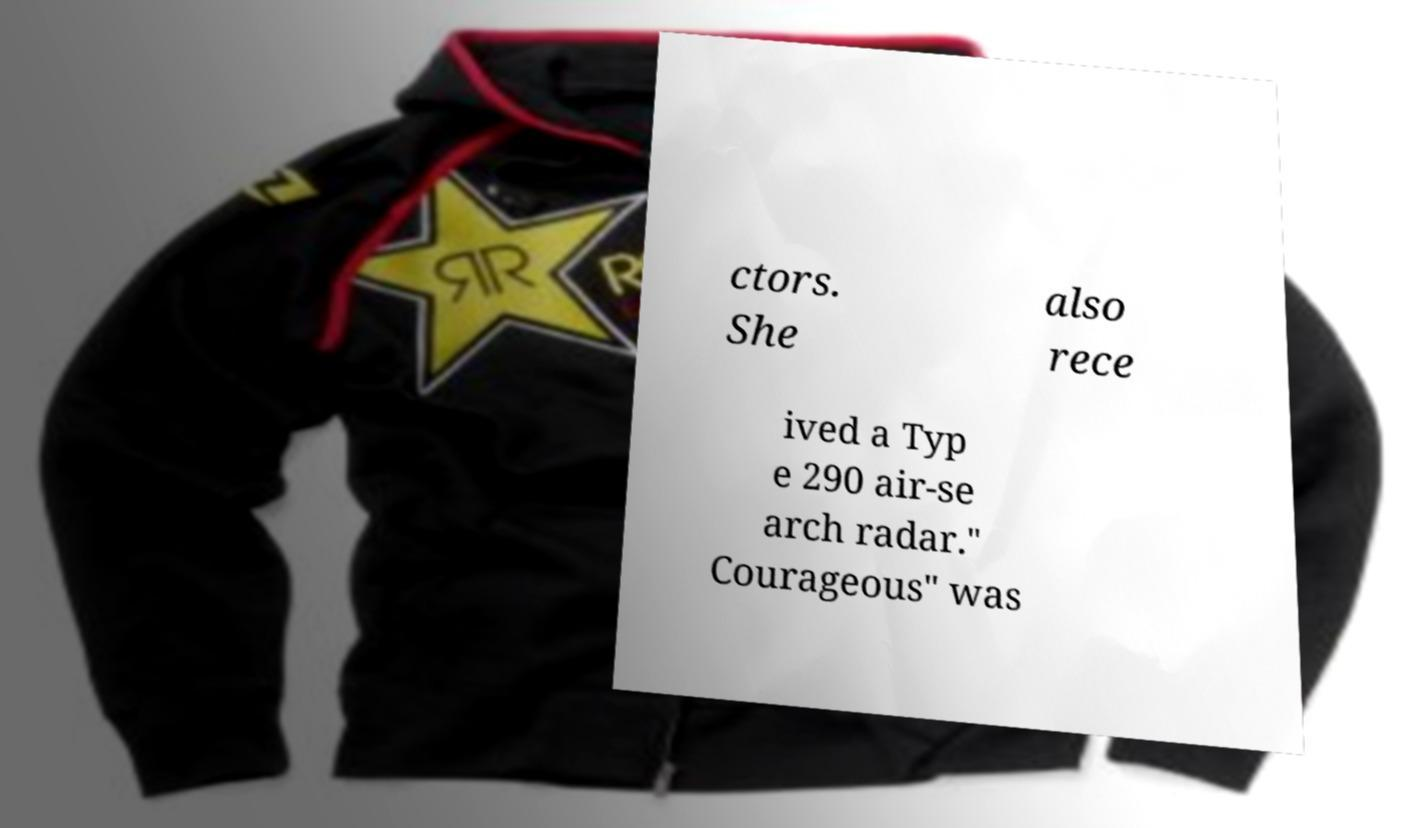Could you assist in decoding the text presented in this image and type it out clearly? ctors. She also rece ived a Typ e 290 air-se arch radar." Courageous" was 